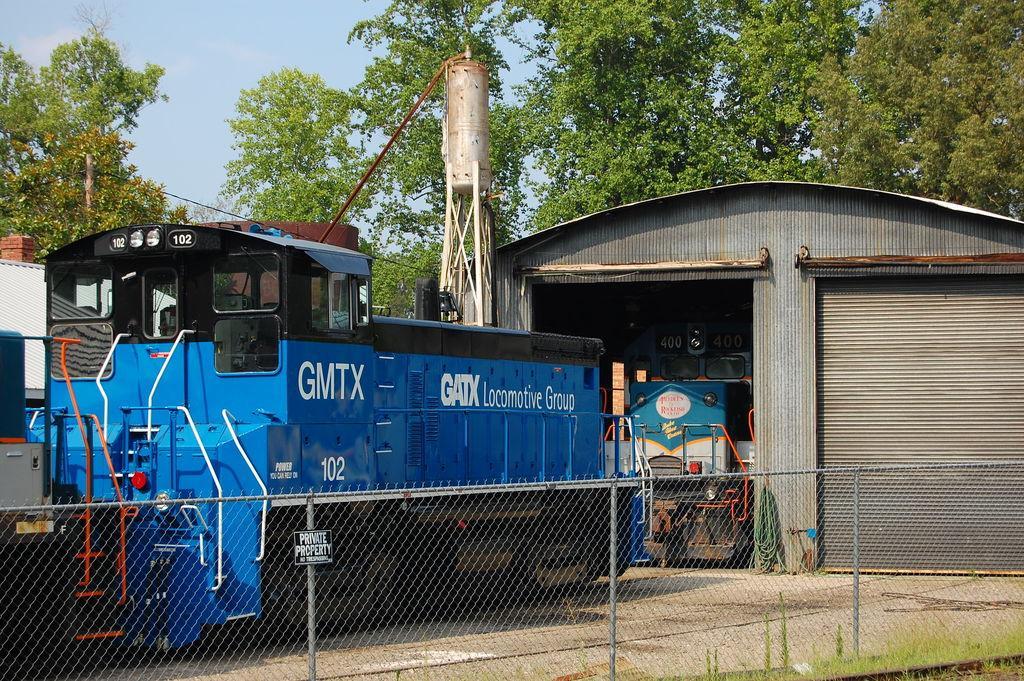In one or two sentences, can you explain what this image depicts? There is a net boundary, shed, tower and trains in the foreground area of the image, there are trees, shed and the sky in the background. 